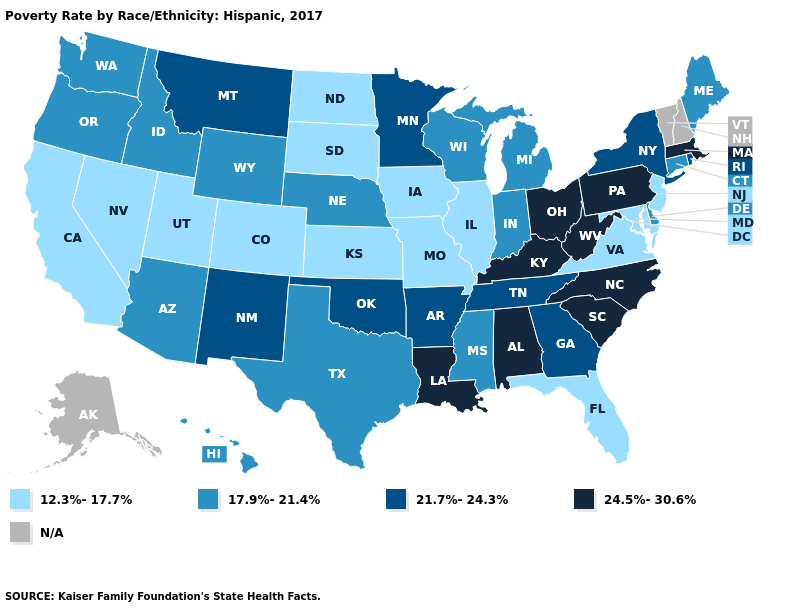Does the map have missing data?
Quick response, please. Yes. What is the value of Oklahoma?
Write a very short answer. 21.7%-24.3%. What is the lowest value in states that border Utah?
Be succinct. 12.3%-17.7%. What is the lowest value in states that border South Carolina?
Keep it brief. 21.7%-24.3%. Among the states that border Delaware , which have the highest value?
Write a very short answer. Pennsylvania. What is the lowest value in the USA?
Write a very short answer. 12.3%-17.7%. How many symbols are there in the legend?
Give a very brief answer. 5. Is the legend a continuous bar?
Concise answer only. No. Among the states that border Nevada , which have the lowest value?
Be succinct. California, Utah. Name the states that have a value in the range N/A?
Give a very brief answer. Alaska, New Hampshire, Vermont. Does Missouri have the highest value in the MidWest?
Write a very short answer. No. What is the value of Oklahoma?
Answer briefly. 21.7%-24.3%. Among the states that border Washington , which have the highest value?
Be succinct. Idaho, Oregon. What is the highest value in the MidWest ?
Give a very brief answer. 24.5%-30.6%. 